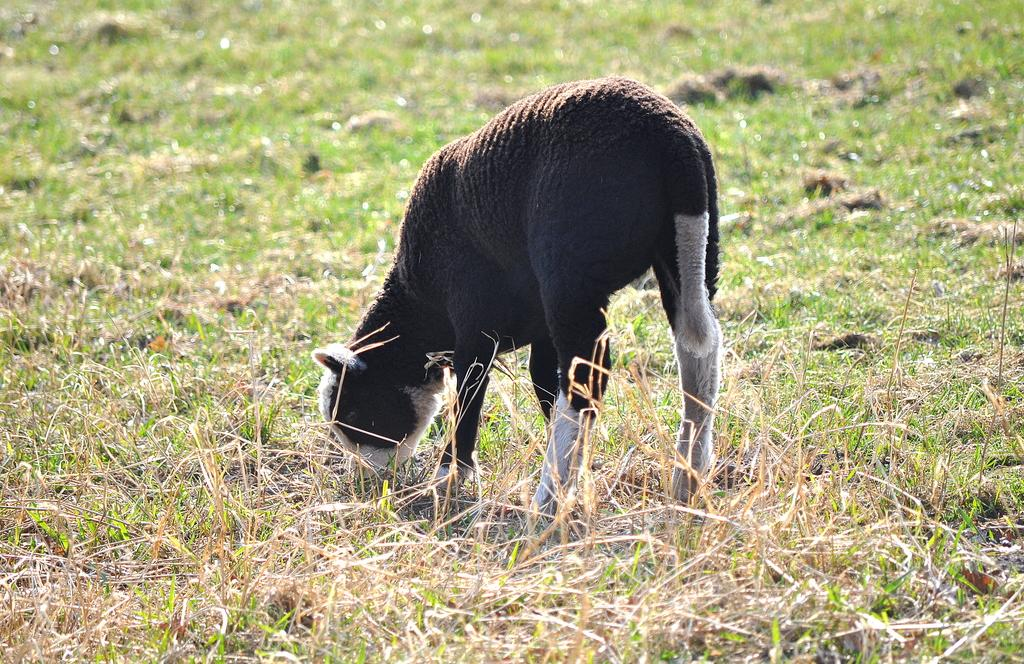What animal is present in the image? There is a lamb in the image. What is the lamb doing in the image? The lamb is grazing the grass. What type of business is the lamb running in the image? There is no indication of a business in the image; it simply shows a lamb grazing the grass. 